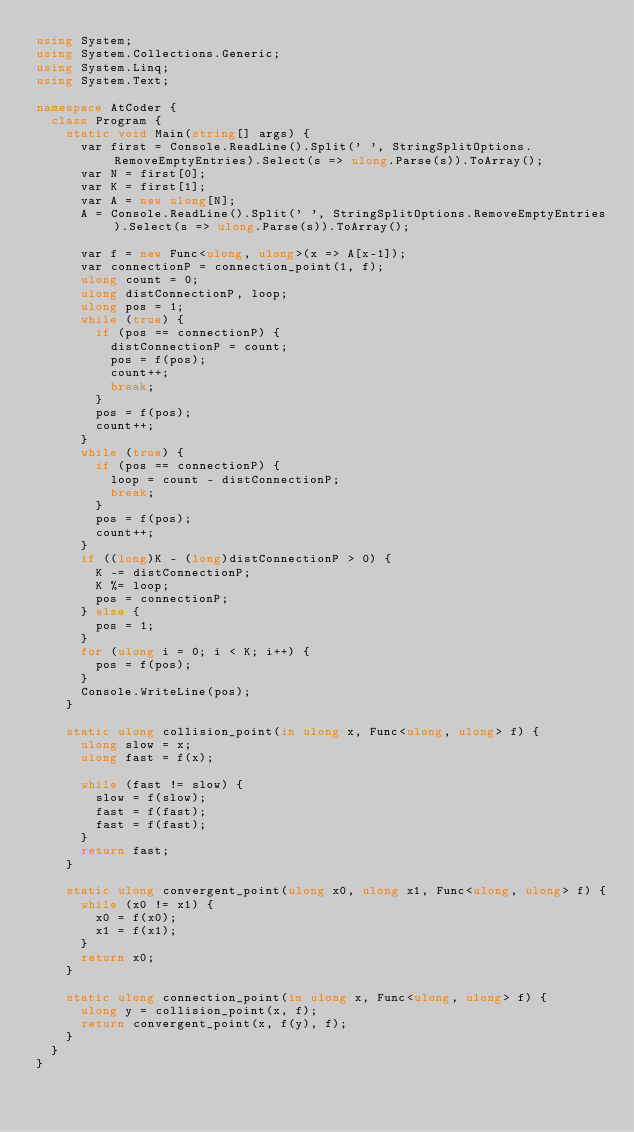Convert code to text. <code><loc_0><loc_0><loc_500><loc_500><_C#_>using System;
using System.Collections.Generic;
using System.Linq;
using System.Text;

namespace AtCoder {
  class Program {
    static void Main(string[] args) {
      var first = Console.ReadLine().Split(' ', StringSplitOptions.RemoveEmptyEntries).Select(s => ulong.Parse(s)).ToArray();
      var N = first[0];
      var K = first[1];
      var A = new ulong[N];
      A = Console.ReadLine().Split(' ', StringSplitOptions.RemoveEmptyEntries).Select(s => ulong.Parse(s)).ToArray();

      var f = new Func<ulong, ulong>(x => A[x-1]);
      var connectionP = connection_point(1, f);
      ulong count = 0;
      ulong distConnectionP, loop;
      ulong pos = 1;
      while (true) {
        if (pos == connectionP) {
          distConnectionP = count;
          pos = f(pos);
          count++;
          break;
        }
        pos = f(pos);
        count++;
      }
      while (true) {
        if (pos == connectionP) {
          loop = count - distConnectionP;
          break;
        }
        pos = f(pos);
        count++;
      }
      if ((long)K - (long)distConnectionP > 0) {
        K -= distConnectionP;
        K %= loop;
        pos = connectionP;
      } else {
        pos = 1;
      }
      for (ulong i = 0; i < K; i++) {
        pos = f(pos);
      }
      Console.WriteLine(pos);
    }

    static ulong collision_point(in ulong x, Func<ulong, ulong> f) {
      ulong slow = x;
      ulong fast = f(x);

      while (fast != slow) {
        slow = f(slow);
        fast = f(fast);
        fast = f(fast);
      }
      return fast;
    }

    static ulong convergent_point(ulong x0, ulong x1, Func<ulong, ulong> f) {
      while (x0 != x1) {
        x0 = f(x0);
        x1 = f(x1);
      }
      return x0;
    }

    static ulong connection_point(in ulong x, Func<ulong, ulong> f) {
      ulong y = collision_point(x, f);
      return convergent_point(x, f(y), f);
    }
  }
}
</code> 